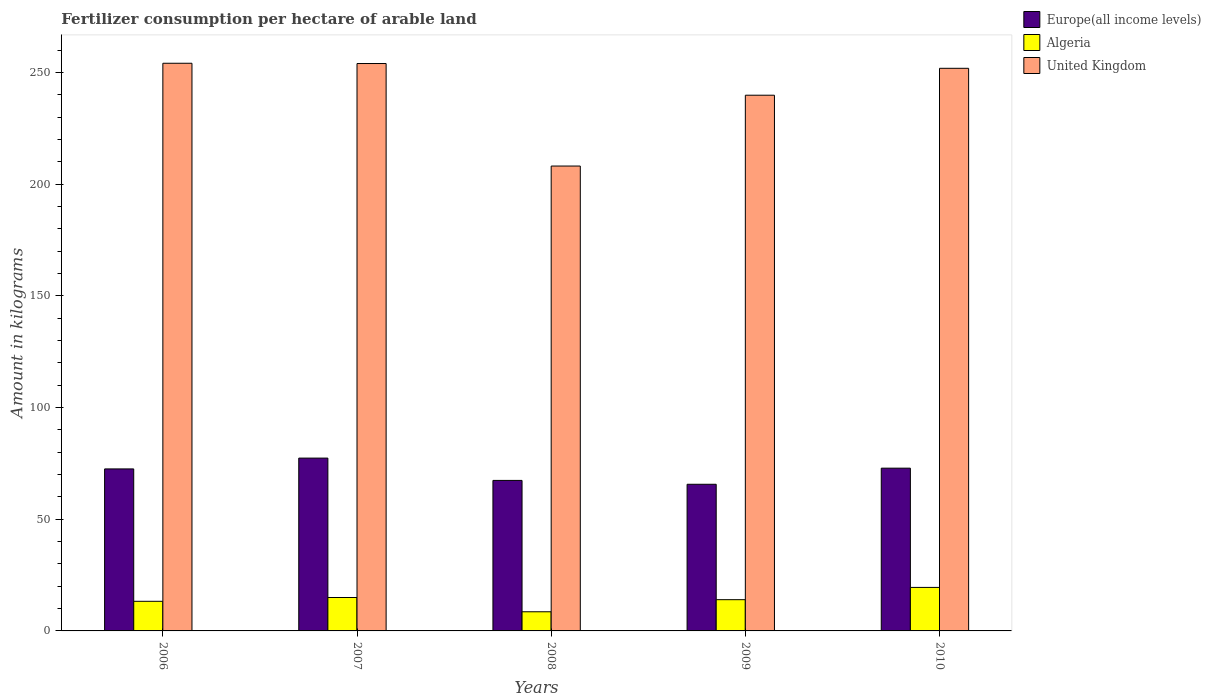Are the number of bars per tick equal to the number of legend labels?
Your response must be concise. Yes. Are the number of bars on each tick of the X-axis equal?
Your response must be concise. Yes. How many bars are there on the 5th tick from the left?
Provide a succinct answer. 3. What is the label of the 4th group of bars from the left?
Make the answer very short. 2009. In how many cases, is the number of bars for a given year not equal to the number of legend labels?
Offer a very short reply. 0. What is the amount of fertilizer consumption in Algeria in 2009?
Keep it short and to the point. 13.99. Across all years, what is the maximum amount of fertilizer consumption in Europe(all income levels)?
Ensure brevity in your answer.  77.39. Across all years, what is the minimum amount of fertilizer consumption in United Kingdom?
Keep it short and to the point. 208.16. In which year was the amount of fertilizer consumption in Europe(all income levels) maximum?
Your answer should be very brief. 2007. What is the total amount of fertilizer consumption in United Kingdom in the graph?
Your response must be concise. 1208.21. What is the difference between the amount of fertilizer consumption in United Kingdom in 2006 and that in 2007?
Your answer should be compact. 0.12. What is the difference between the amount of fertilizer consumption in Europe(all income levels) in 2008 and the amount of fertilizer consumption in Algeria in 2006?
Ensure brevity in your answer.  54.13. What is the average amount of fertilizer consumption in Europe(all income levels) per year?
Keep it short and to the point. 71.17. In the year 2009, what is the difference between the amount of fertilizer consumption in Algeria and amount of fertilizer consumption in United Kingdom?
Ensure brevity in your answer.  -225.89. What is the ratio of the amount of fertilizer consumption in United Kingdom in 2009 to that in 2010?
Your answer should be compact. 0.95. Is the amount of fertilizer consumption in United Kingdom in 2008 less than that in 2009?
Make the answer very short. Yes. What is the difference between the highest and the second highest amount of fertilizer consumption in United Kingdom?
Provide a short and direct response. 0.12. What is the difference between the highest and the lowest amount of fertilizer consumption in Europe(all income levels)?
Your response must be concise. 11.72. In how many years, is the amount of fertilizer consumption in United Kingdom greater than the average amount of fertilizer consumption in United Kingdom taken over all years?
Offer a terse response. 3. Is the sum of the amount of fertilizer consumption in United Kingdom in 2006 and 2010 greater than the maximum amount of fertilizer consumption in Europe(all income levels) across all years?
Offer a very short reply. Yes. What does the 2nd bar from the left in 2008 represents?
Offer a very short reply. Algeria. What does the 3rd bar from the right in 2008 represents?
Offer a very short reply. Europe(all income levels). Is it the case that in every year, the sum of the amount of fertilizer consumption in Europe(all income levels) and amount of fertilizer consumption in Algeria is greater than the amount of fertilizer consumption in United Kingdom?
Ensure brevity in your answer.  No. Are all the bars in the graph horizontal?
Give a very brief answer. No. Does the graph contain grids?
Ensure brevity in your answer.  No. How many legend labels are there?
Make the answer very short. 3. How are the legend labels stacked?
Your response must be concise. Vertical. What is the title of the graph?
Give a very brief answer. Fertilizer consumption per hectare of arable land. What is the label or title of the X-axis?
Offer a very short reply. Years. What is the label or title of the Y-axis?
Offer a terse response. Amount in kilograms. What is the Amount in kilograms of Europe(all income levels) in 2006?
Give a very brief answer. 72.54. What is the Amount in kilograms in Algeria in 2006?
Provide a short and direct response. 13.26. What is the Amount in kilograms in United Kingdom in 2006?
Give a very brief answer. 254.18. What is the Amount in kilograms in Europe(all income levels) in 2007?
Offer a very short reply. 77.39. What is the Amount in kilograms in Algeria in 2007?
Ensure brevity in your answer.  14.96. What is the Amount in kilograms in United Kingdom in 2007?
Your answer should be compact. 254.07. What is the Amount in kilograms of Europe(all income levels) in 2008?
Offer a terse response. 67.39. What is the Amount in kilograms in Algeria in 2008?
Your response must be concise. 8.58. What is the Amount in kilograms in United Kingdom in 2008?
Your response must be concise. 208.16. What is the Amount in kilograms of Europe(all income levels) in 2009?
Make the answer very short. 65.66. What is the Amount in kilograms in Algeria in 2009?
Your answer should be compact. 13.99. What is the Amount in kilograms of United Kingdom in 2009?
Give a very brief answer. 239.87. What is the Amount in kilograms of Europe(all income levels) in 2010?
Ensure brevity in your answer.  72.88. What is the Amount in kilograms in Algeria in 2010?
Ensure brevity in your answer.  19.48. What is the Amount in kilograms of United Kingdom in 2010?
Your answer should be compact. 251.93. Across all years, what is the maximum Amount in kilograms of Europe(all income levels)?
Offer a very short reply. 77.39. Across all years, what is the maximum Amount in kilograms in Algeria?
Your response must be concise. 19.48. Across all years, what is the maximum Amount in kilograms in United Kingdom?
Give a very brief answer. 254.18. Across all years, what is the minimum Amount in kilograms in Europe(all income levels)?
Give a very brief answer. 65.66. Across all years, what is the minimum Amount in kilograms of Algeria?
Your answer should be very brief. 8.58. Across all years, what is the minimum Amount in kilograms of United Kingdom?
Keep it short and to the point. 208.16. What is the total Amount in kilograms in Europe(all income levels) in the graph?
Keep it short and to the point. 355.87. What is the total Amount in kilograms in Algeria in the graph?
Ensure brevity in your answer.  70.27. What is the total Amount in kilograms in United Kingdom in the graph?
Give a very brief answer. 1208.21. What is the difference between the Amount in kilograms of Europe(all income levels) in 2006 and that in 2007?
Offer a terse response. -4.85. What is the difference between the Amount in kilograms in Algeria in 2006 and that in 2007?
Provide a succinct answer. -1.7. What is the difference between the Amount in kilograms in United Kingdom in 2006 and that in 2007?
Keep it short and to the point. 0.12. What is the difference between the Amount in kilograms of Europe(all income levels) in 2006 and that in 2008?
Make the answer very short. 5.15. What is the difference between the Amount in kilograms in Algeria in 2006 and that in 2008?
Make the answer very short. 4.69. What is the difference between the Amount in kilograms of United Kingdom in 2006 and that in 2008?
Provide a succinct answer. 46.02. What is the difference between the Amount in kilograms in Europe(all income levels) in 2006 and that in 2009?
Provide a short and direct response. 6.88. What is the difference between the Amount in kilograms of Algeria in 2006 and that in 2009?
Your answer should be very brief. -0.72. What is the difference between the Amount in kilograms of United Kingdom in 2006 and that in 2009?
Offer a terse response. 14.31. What is the difference between the Amount in kilograms of Europe(all income levels) in 2006 and that in 2010?
Give a very brief answer. -0.34. What is the difference between the Amount in kilograms in Algeria in 2006 and that in 2010?
Give a very brief answer. -6.22. What is the difference between the Amount in kilograms in United Kingdom in 2006 and that in 2010?
Offer a terse response. 2.26. What is the difference between the Amount in kilograms in Europe(all income levels) in 2007 and that in 2008?
Provide a succinct answer. 9.99. What is the difference between the Amount in kilograms in Algeria in 2007 and that in 2008?
Your answer should be compact. 6.38. What is the difference between the Amount in kilograms in United Kingdom in 2007 and that in 2008?
Keep it short and to the point. 45.91. What is the difference between the Amount in kilograms of Europe(all income levels) in 2007 and that in 2009?
Offer a very short reply. 11.72. What is the difference between the Amount in kilograms of Algeria in 2007 and that in 2009?
Ensure brevity in your answer.  0.97. What is the difference between the Amount in kilograms of United Kingdom in 2007 and that in 2009?
Your answer should be compact. 14.19. What is the difference between the Amount in kilograms of Europe(all income levels) in 2007 and that in 2010?
Your answer should be compact. 4.51. What is the difference between the Amount in kilograms of Algeria in 2007 and that in 2010?
Make the answer very short. -4.52. What is the difference between the Amount in kilograms in United Kingdom in 2007 and that in 2010?
Keep it short and to the point. 2.14. What is the difference between the Amount in kilograms in Europe(all income levels) in 2008 and that in 2009?
Your answer should be compact. 1.73. What is the difference between the Amount in kilograms of Algeria in 2008 and that in 2009?
Give a very brief answer. -5.41. What is the difference between the Amount in kilograms of United Kingdom in 2008 and that in 2009?
Your answer should be very brief. -31.71. What is the difference between the Amount in kilograms in Europe(all income levels) in 2008 and that in 2010?
Keep it short and to the point. -5.49. What is the difference between the Amount in kilograms of Algeria in 2008 and that in 2010?
Make the answer very short. -10.9. What is the difference between the Amount in kilograms in United Kingdom in 2008 and that in 2010?
Make the answer very short. -43.77. What is the difference between the Amount in kilograms of Europe(all income levels) in 2009 and that in 2010?
Ensure brevity in your answer.  -7.22. What is the difference between the Amount in kilograms in Algeria in 2009 and that in 2010?
Give a very brief answer. -5.49. What is the difference between the Amount in kilograms in United Kingdom in 2009 and that in 2010?
Your response must be concise. -12.05. What is the difference between the Amount in kilograms in Europe(all income levels) in 2006 and the Amount in kilograms in Algeria in 2007?
Offer a very short reply. 57.58. What is the difference between the Amount in kilograms of Europe(all income levels) in 2006 and the Amount in kilograms of United Kingdom in 2007?
Provide a short and direct response. -181.53. What is the difference between the Amount in kilograms of Algeria in 2006 and the Amount in kilograms of United Kingdom in 2007?
Offer a very short reply. -240.8. What is the difference between the Amount in kilograms in Europe(all income levels) in 2006 and the Amount in kilograms in Algeria in 2008?
Offer a terse response. 63.96. What is the difference between the Amount in kilograms in Europe(all income levels) in 2006 and the Amount in kilograms in United Kingdom in 2008?
Offer a terse response. -135.62. What is the difference between the Amount in kilograms of Algeria in 2006 and the Amount in kilograms of United Kingdom in 2008?
Offer a very short reply. -194.9. What is the difference between the Amount in kilograms in Europe(all income levels) in 2006 and the Amount in kilograms in Algeria in 2009?
Your response must be concise. 58.55. What is the difference between the Amount in kilograms of Europe(all income levels) in 2006 and the Amount in kilograms of United Kingdom in 2009?
Your answer should be very brief. -167.33. What is the difference between the Amount in kilograms in Algeria in 2006 and the Amount in kilograms in United Kingdom in 2009?
Your response must be concise. -226.61. What is the difference between the Amount in kilograms of Europe(all income levels) in 2006 and the Amount in kilograms of Algeria in 2010?
Give a very brief answer. 53.06. What is the difference between the Amount in kilograms in Europe(all income levels) in 2006 and the Amount in kilograms in United Kingdom in 2010?
Make the answer very short. -179.39. What is the difference between the Amount in kilograms in Algeria in 2006 and the Amount in kilograms in United Kingdom in 2010?
Keep it short and to the point. -238.66. What is the difference between the Amount in kilograms of Europe(all income levels) in 2007 and the Amount in kilograms of Algeria in 2008?
Ensure brevity in your answer.  68.81. What is the difference between the Amount in kilograms in Europe(all income levels) in 2007 and the Amount in kilograms in United Kingdom in 2008?
Offer a terse response. -130.77. What is the difference between the Amount in kilograms of Algeria in 2007 and the Amount in kilograms of United Kingdom in 2008?
Make the answer very short. -193.2. What is the difference between the Amount in kilograms in Europe(all income levels) in 2007 and the Amount in kilograms in Algeria in 2009?
Offer a very short reply. 63.4. What is the difference between the Amount in kilograms in Europe(all income levels) in 2007 and the Amount in kilograms in United Kingdom in 2009?
Provide a succinct answer. -162.49. What is the difference between the Amount in kilograms of Algeria in 2007 and the Amount in kilograms of United Kingdom in 2009?
Provide a succinct answer. -224.91. What is the difference between the Amount in kilograms in Europe(all income levels) in 2007 and the Amount in kilograms in Algeria in 2010?
Your response must be concise. 57.91. What is the difference between the Amount in kilograms in Europe(all income levels) in 2007 and the Amount in kilograms in United Kingdom in 2010?
Your answer should be very brief. -174.54. What is the difference between the Amount in kilograms of Algeria in 2007 and the Amount in kilograms of United Kingdom in 2010?
Your answer should be compact. -236.96. What is the difference between the Amount in kilograms of Europe(all income levels) in 2008 and the Amount in kilograms of Algeria in 2009?
Your answer should be compact. 53.41. What is the difference between the Amount in kilograms of Europe(all income levels) in 2008 and the Amount in kilograms of United Kingdom in 2009?
Give a very brief answer. -172.48. What is the difference between the Amount in kilograms in Algeria in 2008 and the Amount in kilograms in United Kingdom in 2009?
Make the answer very short. -231.3. What is the difference between the Amount in kilograms of Europe(all income levels) in 2008 and the Amount in kilograms of Algeria in 2010?
Keep it short and to the point. 47.91. What is the difference between the Amount in kilograms of Europe(all income levels) in 2008 and the Amount in kilograms of United Kingdom in 2010?
Make the answer very short. -184.53. What is the difference between the Amount in kilograms in Algeria in 2008 and the Amount in kilograms in United Kingdom in 2010?
Provide a succinct answer. -243.35. What is the difference between the Amount in kilograms of Europe(all income levels) in 2009 and the Amount in kilograms of Algeria in 2010?
Offer a very short reply. 46.18. What is the difference between the Amount in kilograms of Europe(all income levels) in 2009 and the Amount in kilograms of United Kingdom in 2010?
Make the answer very short. -186.26. What is the difference between the Amount in kilograms in Algeria in 2009 and the Amount in kilograms in United Kingdom in 2010?
Provide a succinct answer. -237.94. What is the average Amount in kilograms of Europe(all income levels) per year?
Offer a terse response. 71.17. What is the average Amount in kilograms in Algeria per year?
Your answer should be very brief. 14.05. What is the average Amount in kilograms in United Kingdom per year?
Your answer should be compact. 241.64. In the year 2006, what is the difference between the Amount in kilograms of Europe(all income levels) and Amount in kilograms of Algeria?
Make the answer very short. 59.28. In the year 2006, what is the difference between the Amount in kilograms of Europe(all income levels) and Amount in kilograms of United Kingdom?
Offer a very short reply. -181.64. In the year 2006, what is the difference between the Amount in kilograms of Algeria and Amount in kilograms of United Kingdom?
Provide a succinct answer. -240.92. In the year 2007, what is the difference between the Amount in kilograms of Europe(all income levels) and Amount in kilograms of Algeria?
Provide a short and direct response. 62.43. In the year 2007, what is the difference between the Amount in kilograms in Europe(all income levels) and Amount in kilograms in United Kingdom?
Your answer should be very brief. -176.68. In the year 2007, what is the difference between the Amount in kilograms of Algeria and Amount in kilograms of United Kingdom?
Ensure brevity in your answer.  -239.11. In the year 2008, what is the difference between the Amount in kilograms in Europe(all income levels) and Amount in kilograms in Algeria?
Your answer should be compact. 58.82. In the year 2008, what is the difference between the Amount in kilograms of Europe(all income levels) and Amount in kilograms of United Kingdom?
Your response must be concise. -140.77. In the year 2008, what is the difference between the Amount in kilograms in Algeria and Amount in kilograms in United Kingdom?
Your answer should be very brief. -199.58. In the year 2009, what is the difference between the Amount in kilograms in Europe(all income levels) and Amount in kilograms in Algeria?
Your answer should be compact. 51.68. In the year 2009, what is the difference between the Amount in kilograms of Europe(all income levels) and Amount in kilograms of United Kingdom?
Offer a terse response. -174.21. In the year 2009, what is the difference between the Amount in kilograms of Algeria and Amount in kilograms of United Kingdom?
Your response must be concise. -225.89. In the year 2010, what is the difference between the Amount in kilograms in Europe(all income levels) and Amount in kilograms in Algeria?
Keep it short and to the point. 53.4. In the year 2010, what is the difference between the Amount in kilograms of Europe(all income levels) and Amount in kilograms of United Kingdom?
Your answer should be compact. -179.04. In the year 2010, what is the difference between the Amount in kilograms of Algeria and Amount in kilograms of United Kingdom?
Your answer should be very brief. -232.44. What is the ratio of the Amount in kilograms in Europe(all income levels) in 2006 to that in 2007?
Give a very brief answer. 0.94. What is the ratio of the Amount in kilograms of Algeria in 2006 to that in 2007?
Offer a very short reply. 0.89. What is the ratio of the Amount in kilograms of United Kingdom in 2006 to that in 2007?
Provide a short and direct response. 1. What is the ratio of the Amount in kilograms in Europe(all income levels) in 2006 to that in 2008?
Ensure brevity in your answer.  1.08. What is the ratio of the Amount in kilograms of Algeria in 2006 to that in 2008?
Provide a succinct answer. 1.55. What is the ratio of the Amount in kilograms of United Kingdom in 2006 to that in 2008?
Your answer should be compact. 1.22. What is the ratio of the Amount in kilograms in Europe(all income levels) in 2006 to that in 2009?
Make the answer very short. 1.1. What is the ratio of the Amount in kilograms in Algeria in 2006 to that in 2009?
Your answer should be very brief. 0.95. What is the ratio of the Amount in kilograms in United Kingdom in 2006 to that in 2009?
Keep it short and to the point. 1.06. What is the ratio of the Amount in kilograms in Algeria in 2006 to that in 2010?
Provide a succinct answer. 0.68. What is the ratio of the Amount in kilograms of Europe(all income levels) in 2007 to that in 2008?
Offer a very short reply. 1.15. What is the ratio of the Amount in kilograms of Algeria in 2007 to that in 2008?
Keep it short and to the point. 1.74. What is the ratio of the Amount in kilograms in United Kingdom in 2007 to that in 2008?
Offer a very short reply. 1.22. What is the ratio of the Amount in kilograms of Europe(all income levels) in 2007 to that in 2009?
Provide a short and direct response. 1.18. What is the ratio of the Amount in kilograms of Algeria in 2007 to that in 2009?
Your answer should be very brief. 1.07. What is the ratio of the Amount in kilograms of United Kingdom in 2007 to that in 2009?
Provide a short and direct response. 1.06. What is the ratio of the Amount in kilograms in Europe(all income levels) in 2007 to that in 2010?
Make the answer very short. 1.06. What is the ratio of the Amount in kilograms in Algeria in 2007 to that in 2010?
Offer a terse response. 0.77. What is the ratio of the Amount in kilograms in United Kingdom in 2007 to that in 2010?
Your answer should be very brief. 1.01. What is the ratio of the Amount in kilograms of Europe(all income levels) in 2008 to that in 2009?
Offer a very short reply. 1.03. What is the ratio of the Amount in kilograms in Algeria in 2008 to that in 2009?
Your response must be concise. 0.61. What is the ratio of the Amount in kilograms in United Kingdom in 2008 to that in 2009?
Ensure brevity in your answer.  0.87. What is the ratio of the Amount in kilograms in Europe(all income levels) in 2008 to that in 2010?
Ensure brevity in your answer.  0.92. What is the ratio of the Amount in kilograms in Algeria in 2008 to that in 2010?
Provide a short and direct response. 0.44. What is the ratio of the Amount in kilograms of United Kingdom in 2008 to that in 2010?
Offer a terse response. 0.83. What is the ratio of the Amount in kilograms in Europe(all income levels) in 2009 to that in 2010?
Provide a short and direct response. 0.9. What is the ratio of the Amount in kilograms in Algeria in 2009 to that in 2010?
Your response must be concise. 0.72. What is the ratio of the Amount in kilograms in United Kingdom in 2009 to that in 2010?
Ensure brevity in your answer.  0.95. What is the difference between the highest and the second highest Amount in kilograms of Europe(all income levels)?
Your answer should be very brief. 4.51. What is the difference between the highest and the second highest Amount in kilograms of Algeria?
Your answer should be compact. 4.52. What is the difference between the highest and the second highest Amount in kilograms in United Kingdom?
Your response must be concise. 0.12. What is the difference between the highest and the lowest Amount in kilograms in Europe(all income levels)?
Keep it short and to the point. 11.72. What is the difference between the highest and the lowest Amount in kilograms of Algeria?
Your answer should be very brief. 10.9. What is the difference between the highest and the lowest Amount in kilograms of United Kingdom?
Your answer should be compact. 46.02. 